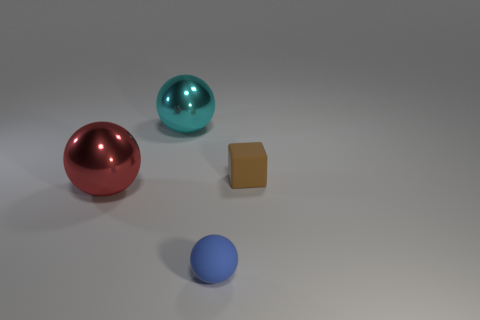What materials do the objects in the picture appear to be made from? The spheres have a reflective surface that suggests they could be made of a polished metal or plastic, while the cube appears to have a matte finish, indicating it might be made of a material like wood or matte plastic. 